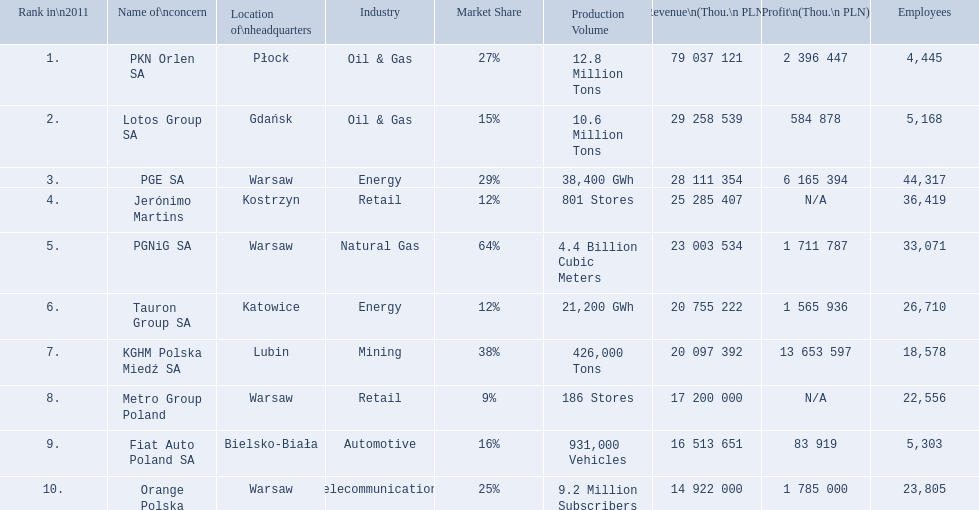What is the number of employees that work for pkn orlen sa in poland? 4,445. What number of employees work for lotos group sa? 5,168. How many people work for pgnig sa? 33,071. 